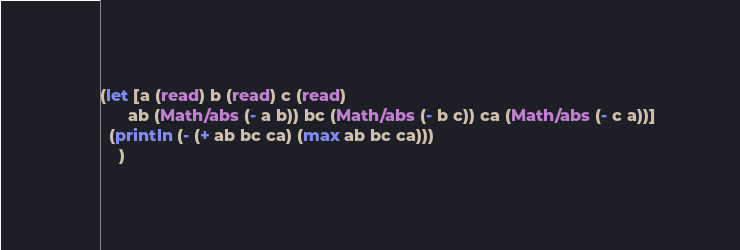Convert code to text. <code><loc_0><loc_0><loc_500><loc_500><_Clojure_>(let [a (read) b (read) c (read)
      ab (Math/abs (- a b)) bc (Math/abs (- b c)) ca (Math/abs (- c a))]
  (println (- (+ ab bc ca) (max ab bc ca)))
  	)</code> 